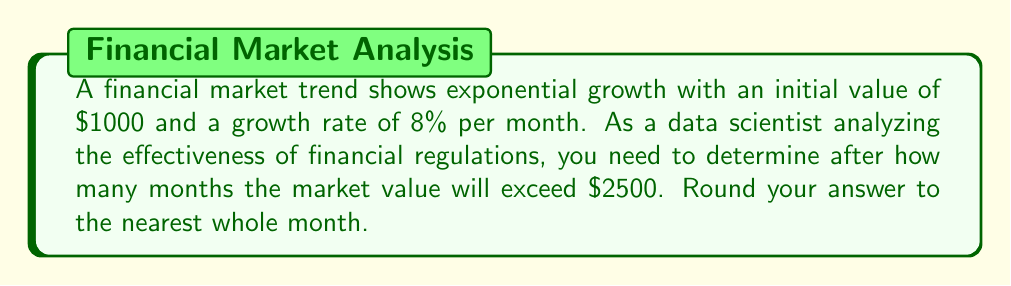Could you help me with this problem? Let's approach this step-by-step:

1) The exponential growth formula is:
   $$A = P(1 + r)^t$$
   where A is the final amount, P is the initial principal, r is the growth rate, and t is the time.

2) We know:
   P = $1000 (initial value)
   r = 8% = 0.08 (growth rate per month)
   A = $2500 (target value)

3) Let's substitute these values into the formula:
   $$2500 = 1000(1 + 0.08)^t$$

4) Divide both sides by 1000:
   $$2.5 = (1.08)^t$$

5) Take the natural logarithm of both sides:
   $$\ln(2.5) = t \ln(1.08)$$

6) Solve for t:
   $$t = \frac{\ln(2.5)}{\ln(1.08)}$$

7) Calculate:
   $$t = \frac{0.9163}{0.0770} \approx 11.90$$

8) Rounding to the nearest whole month:
   t ≈ 12 months
Answer: 12 months 